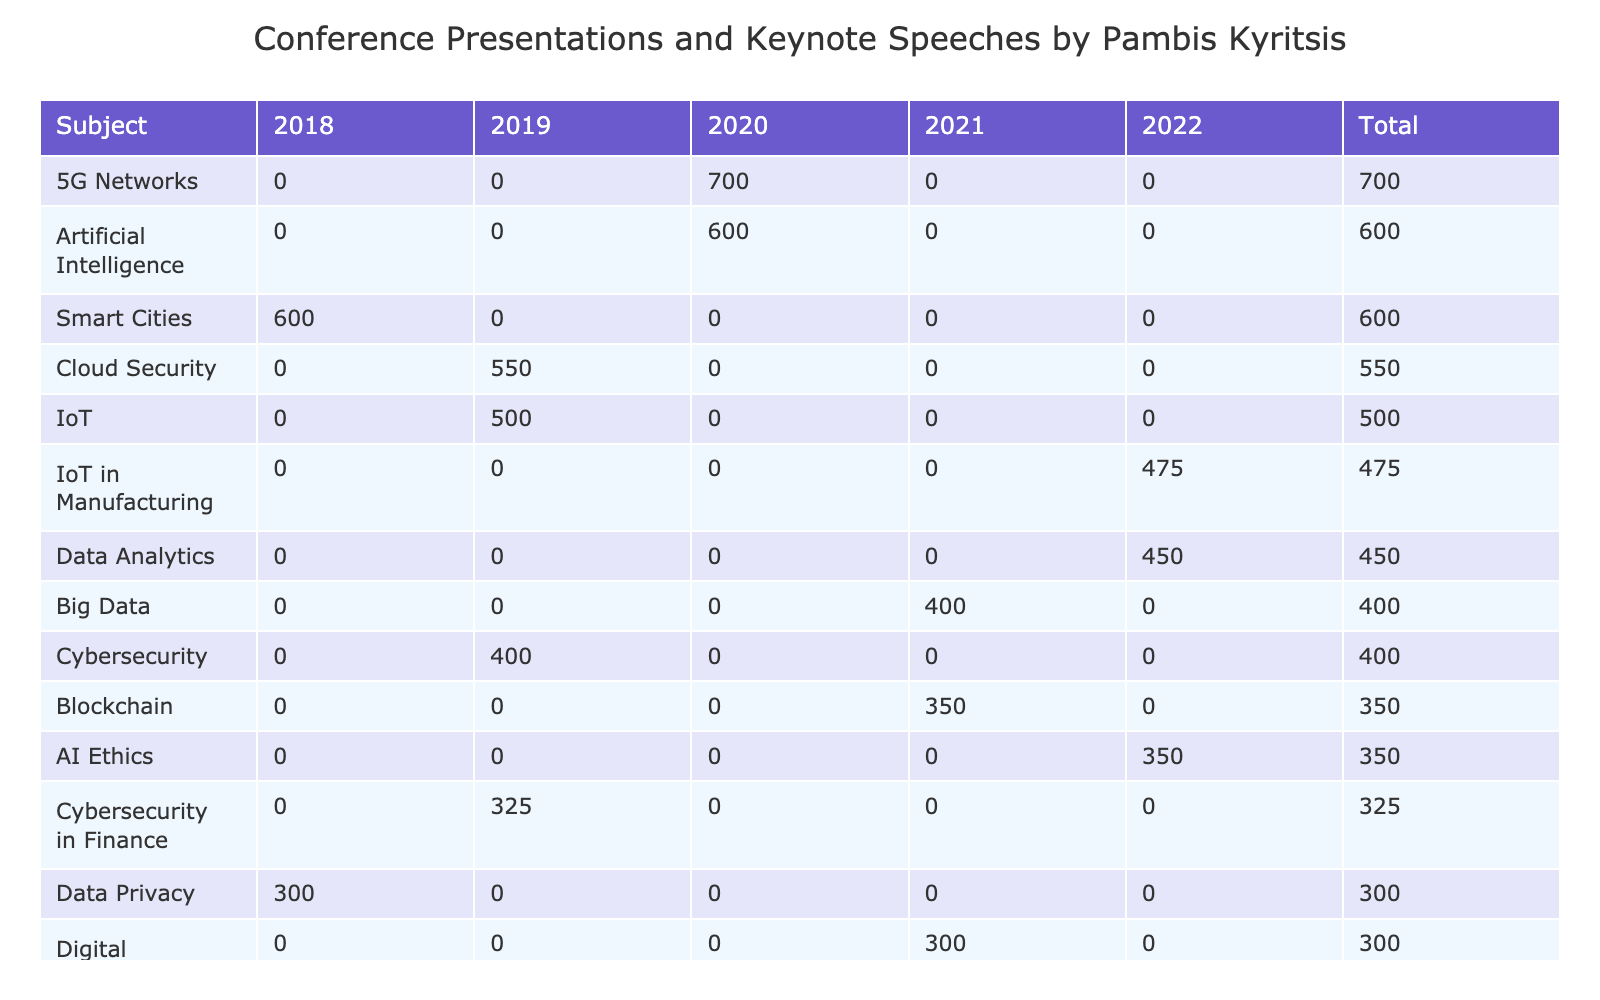What was the audience size for the Blockchain presentation in 2021? Referring to the table, under the subject "Blockchain" and the year "2021," the audience size listed is 350.
Answer: 350 In which year did Pambis Kyritsis first present on Cloud Computing? The table lists "Cloud Computing" with a presentation year of 2018, which is the earliest year presented for that subject.
Answer: 2018 What is the total audience size for Cybersecurity across all years? The audience sizes for Cybersecurity are 400 (2019) and 325 (2019, specific to Finance). Adding these gives a total of 400 + 325 = 725.
Answer: 725 Is there a presentation on AI Ethics in 2020? The table shows that there is no entry for AI Ethics in 2020; thus, the answer is no.
Answer: No Which subject had the highest audience size in 2020, and what was that size? Looking at the table, the subjects and audience sizes for 2020 are: AI (600), 5G Networks (700), and AI in Healthcare (225). The subject with the highest audience size is 5G Networks with an audience of 700.
Answer: 5G Networks, 700 What is the average audience size for the presentations in the year 2021? For 2021, the audience sizes are as follows: 300 (Digital Transformation), 350 (Blockchain), 400 (Big Data), and 175 (Blockchain for Supply Chain). Adding these yields 300 + 350 + 400 + 175 = 1225. Then, dividing by the number of subjects (4) gives us an average of 1225 / 4 = 306.25.
Answer: 306.25 How many subjects had an audience size greater than 500? By examining the table, the subjects with an audience size greater than 500 are: Artificial Intelligence (600), 5G Networks (700), and Smart Cities (600). Thus, there are three subjects meeting this criterion.
Answer: 3 What was the total audience size for presentations in 2019? Summing the audience sizes for 2019 gives: Cybersecurity (400) + Cloud Security (550) + Cybersecurity in Finance (325) = 1275. Thus, the total audience size for 2019 is 1275.
Answer: 1275 Was the audience size higher for IoT in Manufacturing or Data Analytics? For IoT in Manufacturing, the audience size in 2022 is 475, whereas the audience size for Data Analytics in 2022 is 450. Since 475 > 450, the audience size for IoT in Manufacturing is higher.
Answer: Yes 